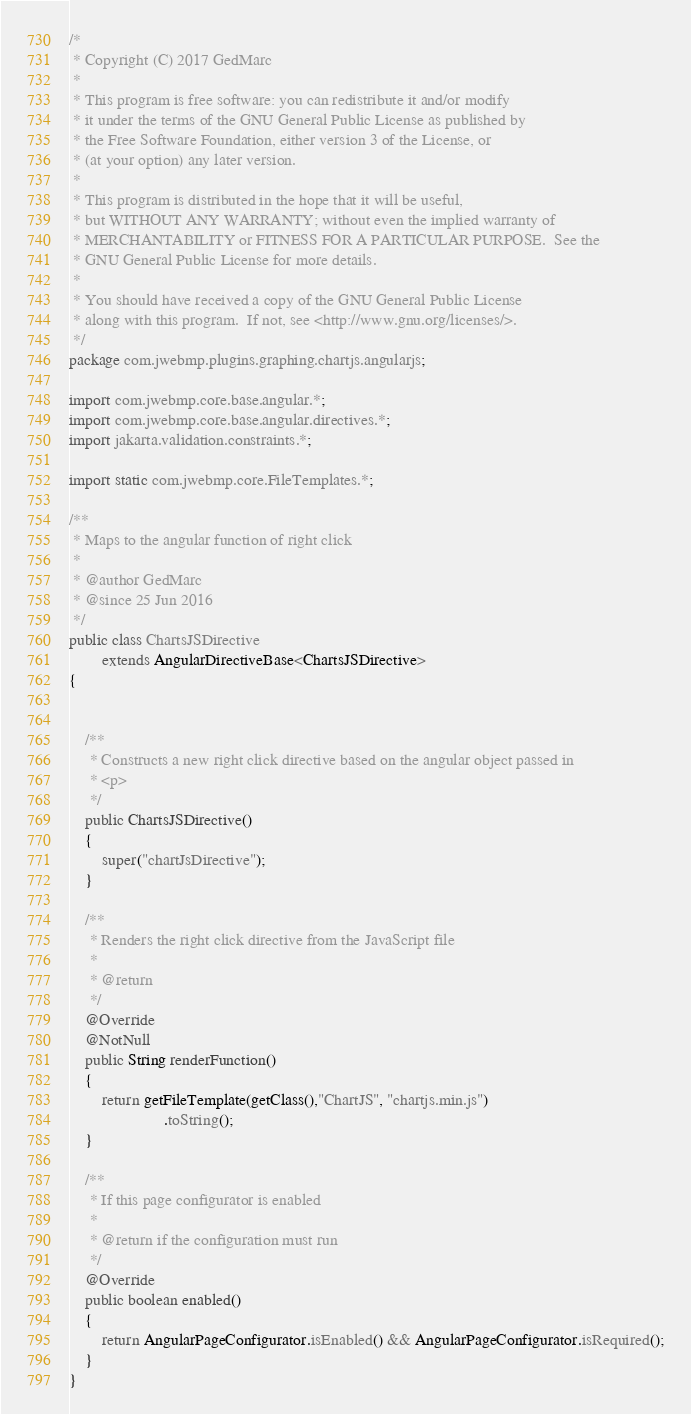<code> <loc_0><loc_0><loc_500><loc_500><_Java_>/*
 * Copyright (C) 2017 GedMarc
 *
 * This program is free software: you can redistribute it and/or modify
 * it under the terms of the GNU General Public License as published by
 * the Free Software Foundation, either version 3 of the License, or
 * (at your option) any later version.
 *
 * This program is distributed in the hope that it will be useful,
 * but WITHOUT ANY WARRANTY; without even the implied warranty of
 * MERCHANTABILITY or FITNESS FOR A PARTICULAR PURPOSE.  See the
 * GNU General Public License for more details.
 *
 * You should have received a copy of the GNU General Public License
 * along with this program.  If not, see <http://www.gnu.org/licenses/>.
 */
package com.jwebmp.plugins.graphing.chartjs.angularjs;

import com.jwebmp.core.base.angular.*;
import com.jwebmp.core.base.angular.directives.*;
import jakarta.validation.constraints.*;

import static com.jwebmp.core.FileTemplates.*;

/**
 * Maps to the angular function of right click
 *
 * @author GedMarc
 * @since 25 Jun 2016
 */
public class ChartsJSDirective
		extends AngularDirectiveBase<ChartsJSDirective>
{


	/**
	 * Constructs a new right click directive based on the angular object passed in
	 * <p>
	 */
	public ChartsJSDirective()
	{
		super("chartJsDirective");
	}

	/**
	 * Renders the right click directive from the JavaScript file
	 *
	 * @return
	 */
	@Override
	@NotNull
	public String renderFunction()
	{
		return getFileTemplate(getClass(),"ChartJS", "chartjs.min.js")
				       .toString();
	}

	/**
	 * If this page configurator is enabled
	 *
	 * @return if the configuration must run
	 */
	@Override
	public boolean enabled()
	{
		return AngularPageConfigurator.isEnabled() && AngularPageConfigurator.isRequired();
	}
}
</code> 